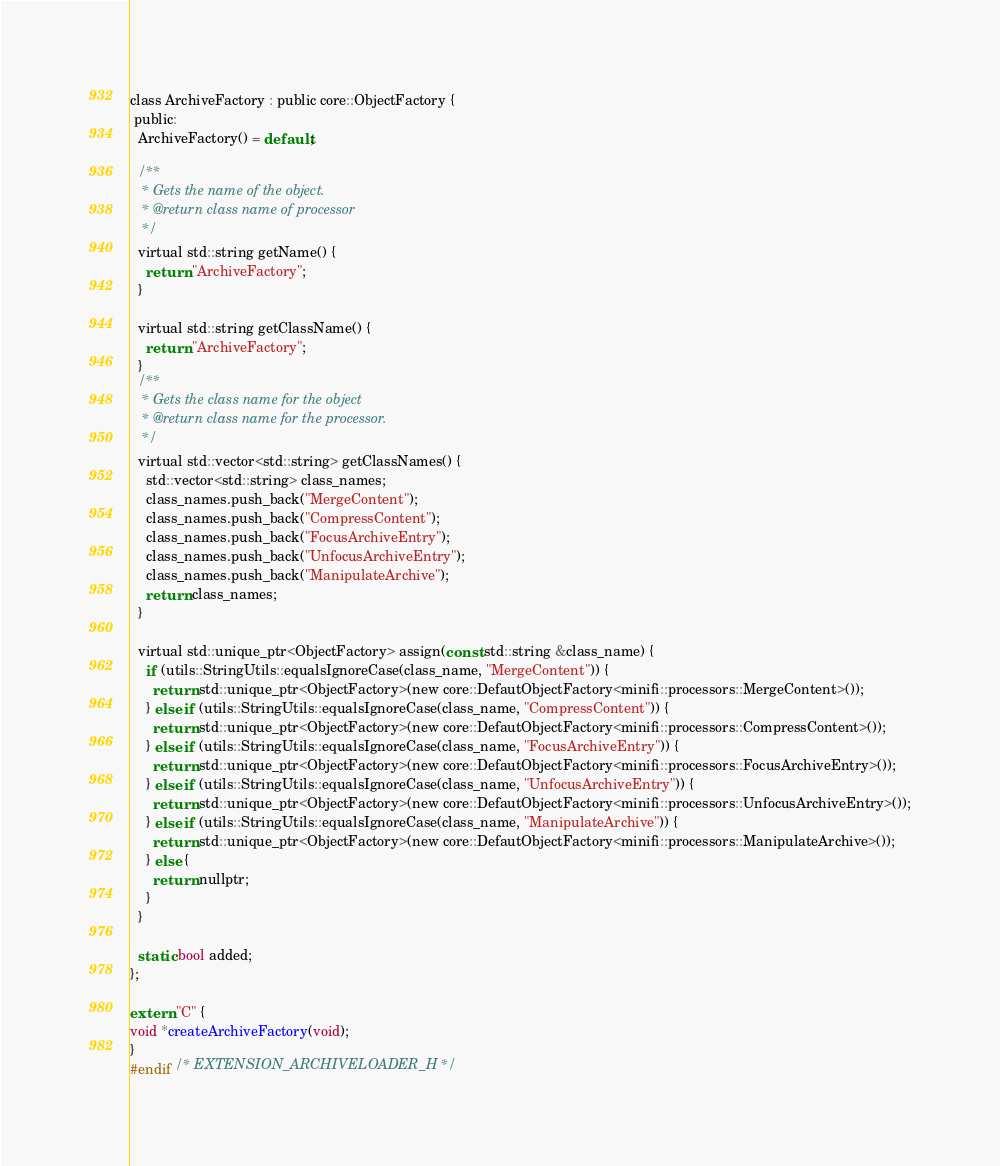Convert code to text. <code><loc_0><loc_0><loc_500><loc_500><_C_>
class ArchiveFactory : public core::ObjectFactory {
 public:
  ArchiveFactory() = default;

  /**
   * Gets the name of the object.
   * @return class name of processor
   */
  virtual std::string getName() {
    return "ArchiveFactory";
  }

  virtual std::string getClassName() {
    return "ArchiveFactory";
  }
  /**
   * Gets the class name for the object
   * @return class name for the processor.
   */
  virtual std::vector<std::string> getClassNames() {
    std::vector<std::string> class_names;
    class_names.push_back("MergeContent");
    class_names.push_back("CompressContent");
    class_names.push_back("FocusArchiveEntry");
    class_names.push_back("UnfocusArchiveEntry");
    class_names.push_back("ManipulateArchive");
    return class_names;
  }

  virtual std::unique_ptr<ObjectFactory> assign(const std::string &class_name) {
    if (utils::StringUtils::equalsIgnoreCase(class_name, "MergeContent")) {
      return std::unique_ptr<ObjectFactory>(new core::DefautObjectFactory<minifi::processors::MergeContent>());
    } else if (utils::StringUtils::equalsIgnoreCase(class_name, "CompressContent")) {
      return std::unique_ptr<ObjectFactory>(new core::DefautObjectFactory<minifi::processors::CompressContent>());
    } else if (utils::StringUtils::equalsIgnoreCase(class_name, "FocusArchiveEntry")) {
      return std::unique_ptr<ObjectFactory>(new core::DefautObjectFactory<minifi::processors::FocusArchiveEntry>());
    } else if (utils::StringUtils::equalsIgnoreCase(class_name, "UnfocusArchiveEntry")) {
      return std::unique_ptr<ObjectFactory>(new core::DefautObjectFactory<minifi::processors::UnfocusArchiveEntry>());
    } else if (utils::StringUtils::equalsIgnoreCase(class_name, "ManipulateArchive")) {
      return std::unique_ptr<ObjectFactory>(new core::DefautObjectFactory<minifi::processors::ManipulateArchive>());
    } else {
      return nullptr;
    }
  }

  static bool added;
};

extern "C" {
void *createArchiveFactory(void);
}
#endif /* EXTENSION_ARCHIVELOADER_H */
</code> 